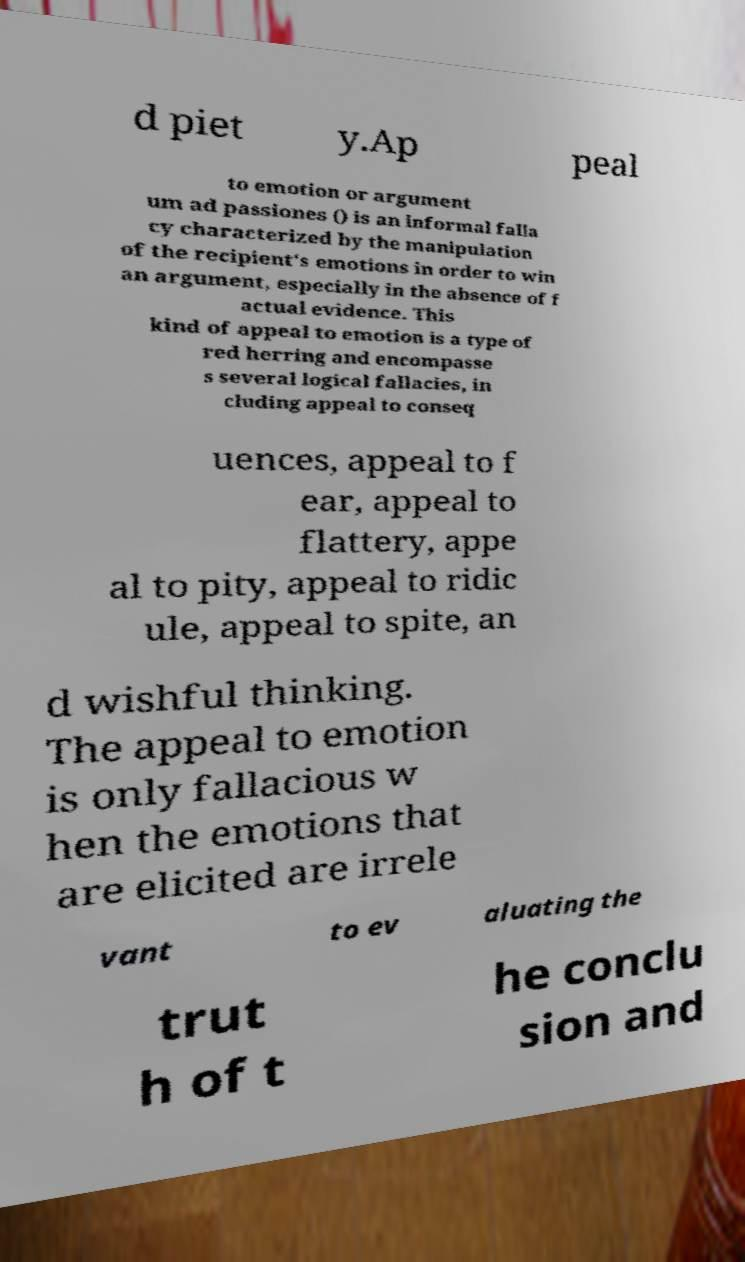Could you extract and type out the text from this image? d piet y.Ap peal to emotion or argument um ad passiones () is an informal falla cy characterized by the manipulation of the recipient's emotions in order to win an argument, especially in the absence of f actual evidence. This kind of appeal to emotion is a type of red herring and encompasse s several logical fallacies, in cluding appeal to conseq uences, appeal to f ear, appeal to flattery, appe al to pity, appeal to ridic ule, appeal to spite, an d wishful thinking. The appeal to emotion is only fallacious w hen the emotions that are elicited are irrele vant to ev aluating the trut h of t he conclu sion and 